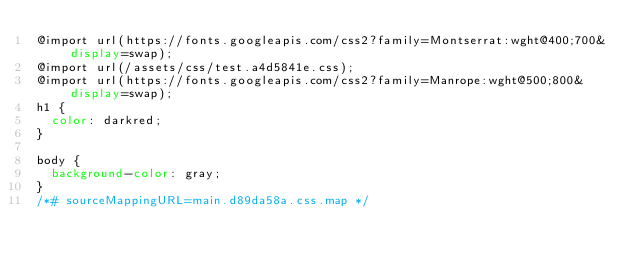<code> <loc_0><loc_0><loc_500><loc_500><_CSS_>@import url(https://fonts.googleapis.com/css2?family=Montserrat:wght@400;700&display=swap);
@import url(/assets/css/test.a4d5841e.css);
@import url(https://fonts.googleapis.com/css2?family=Manrope:wght@500;800&display=swap);
h1 {
  color: darkred;
}

body {
  background-color: gray;
}
/*# sourceMappingURL=main.d89da58a.css.map */</code> 